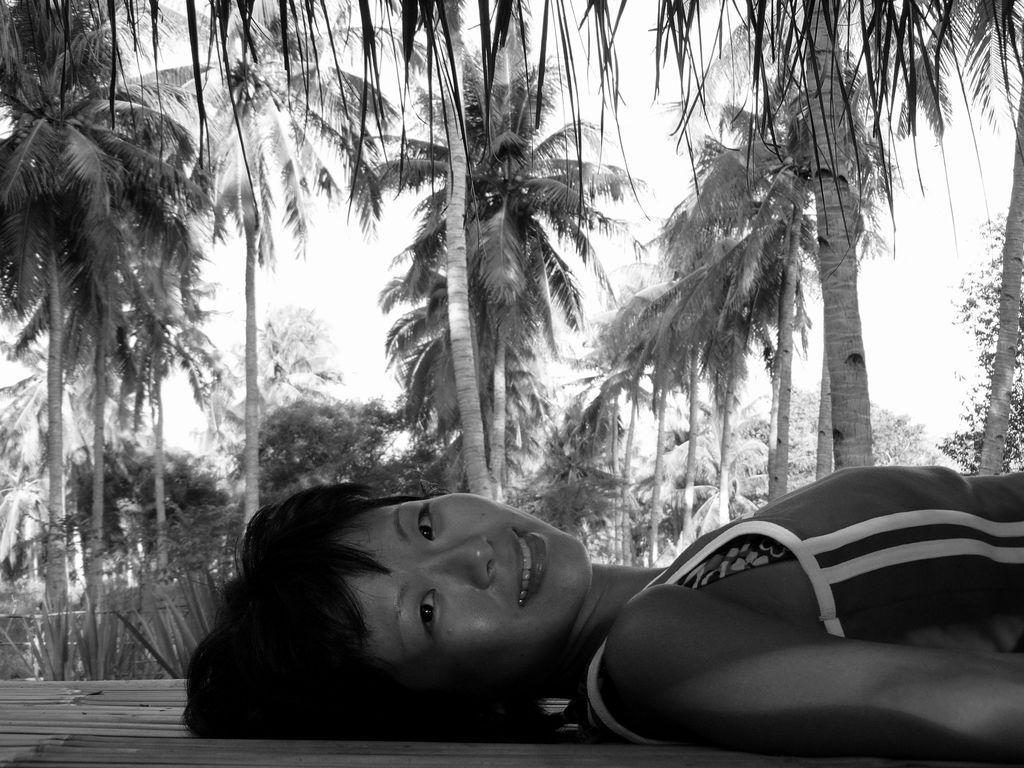In one or two sentences, can you explain what this image depicts? In this image we can see a person lying on a surface. Behind the person we can see a group of trees. At the top we can see the sky. 